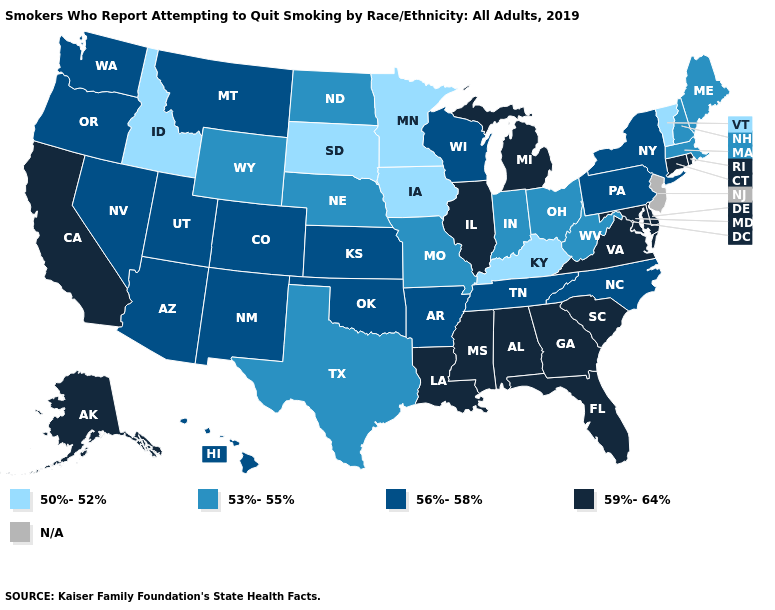What is the highest value in the Northeast ?
Quick response, please. 59%-64%. Among the states that border Washington , which have the lowest value?
Write a very short answer. Idaho. Does Tennessee have the highest value in the USA?
Answer briefly. No. Which states have the lowest value in the South?
Write a very short answer. Kentucky. Which states have the lowest value in the USA?
Keep it brief. Idaho, Iowa, Kentucky, Minnesota, South Dakota, Vermont. What is the lowest value in states that border Florida?
Short answer required. 59%-64%. What is the lowest value in the Northeast?
Give a very brief answer. 50%-52%. What is the value of Montana?
Keep it brief. 56%-58%. What is the highest value in the Northeast ?
Give a very brief answer. 59%-64%. Which states have the lowest value in the USA?
Concise answer only. Idaho, Iowa, Kentucky, Minnesota, South Dakota, Vermont. What is the value of Utah?
Keep it brief. 56%-58%. Name the states that have a value in the range 59%-64%?
Quick response, please. Alabama, Alaska, California, Connecticut, Delaware, Florida, Georgia, Illinois, Louisiana, Maryland, Michigan, Mississippi, Rhode Island, South Carolina, Virginia. Name the states that have a value in the range 50%-52%?
Give a very brief answer. Idaho, Iowa, Kentucky, Minnesota, South Dakota, Vermont. Name the states that have a value in the range 59%-64%?
Quick response, please. Alabama, Alaska, California, Connecticut, Delaware, Florida, Georgia, Illinois, Louisiana, Maryland, Michigan, Mississippi, Rhode Island, South Carolina, Virginia. 